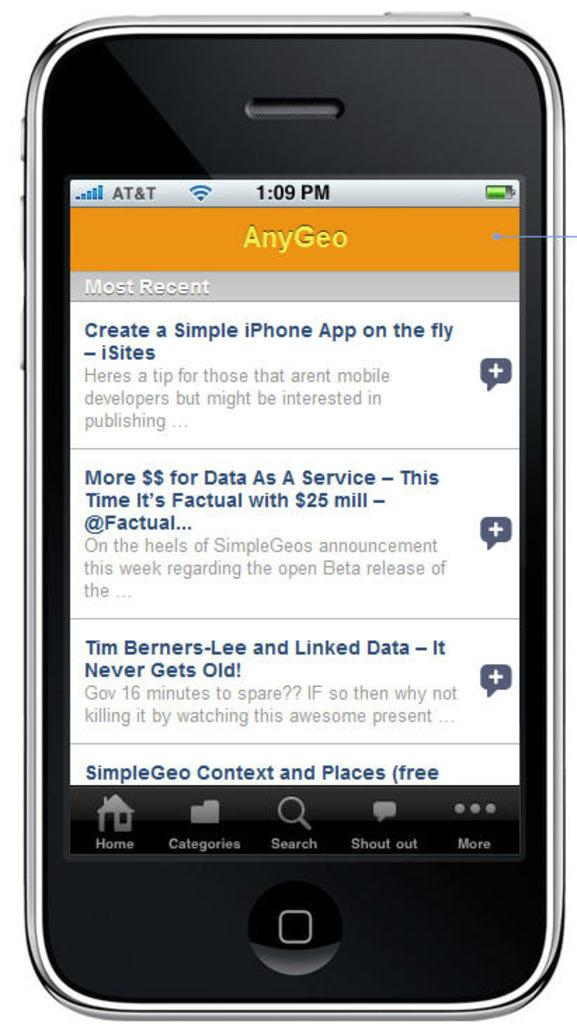<image>
Present a compact description of the photo's key features. An Apple iphone is shown using the AnyGeo app. 